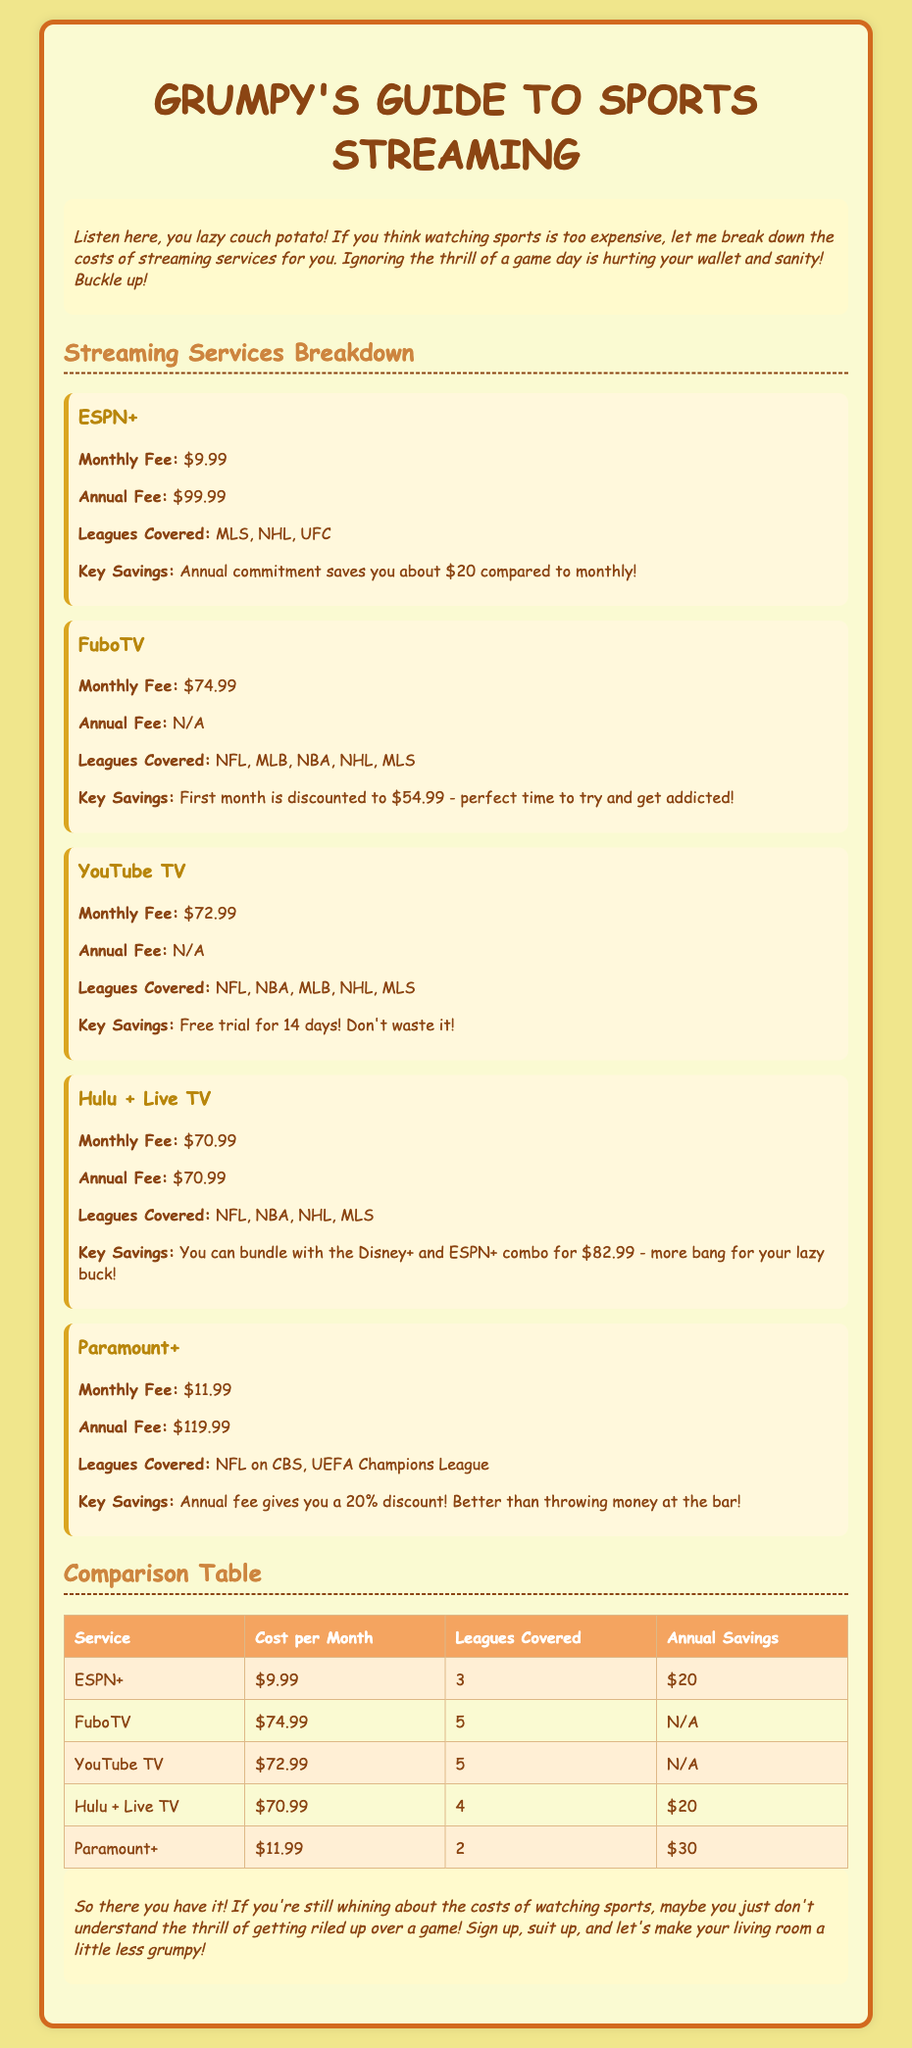What is the monthly fee for ESPN+? The document states the monthly fee for ESPN+ is $9.99.
Answer: $9.99 Which leagues does FuboTV cover? The document mentions that FuboTV covers NFL, MLB, NBA, NHL, and MLS.
Answer: NFL, MLB, NBA, NHL, MLS What is the discount for the annual fee of Paramount+? The document indicates that the annual fee gives a 20% discount compared to the monthly fee.
Answer: 20% Which service has the lowest monthly fee? By comparing the monthly fees, ESPN+ at $9.99 has the lowest fee.
Answer: $9.99 How many leagues does Hulu + Live TV cover? The document states that Hulu + Live TV covers 4 leagues.
Answer: 4 What is the key saving for the annual commitment of ESPN+? The document states that the annual commitment saves you about $20 compared to monthly payments.
Answer: $20 What is the promotional price for the first month of FuboTV? The document mentions that the first month of FuboTV is discounted to $54.99.
Answer: $54.99 Which service offers a free trial? The document notes that YouTube TV offers a free trial for 14 days.
Answer: 14 days What is the bundled price of Hulu + Live TV with Disney+ and ESPN+? The document indicates the bundle price is $82.99.
Answer: $82.99 